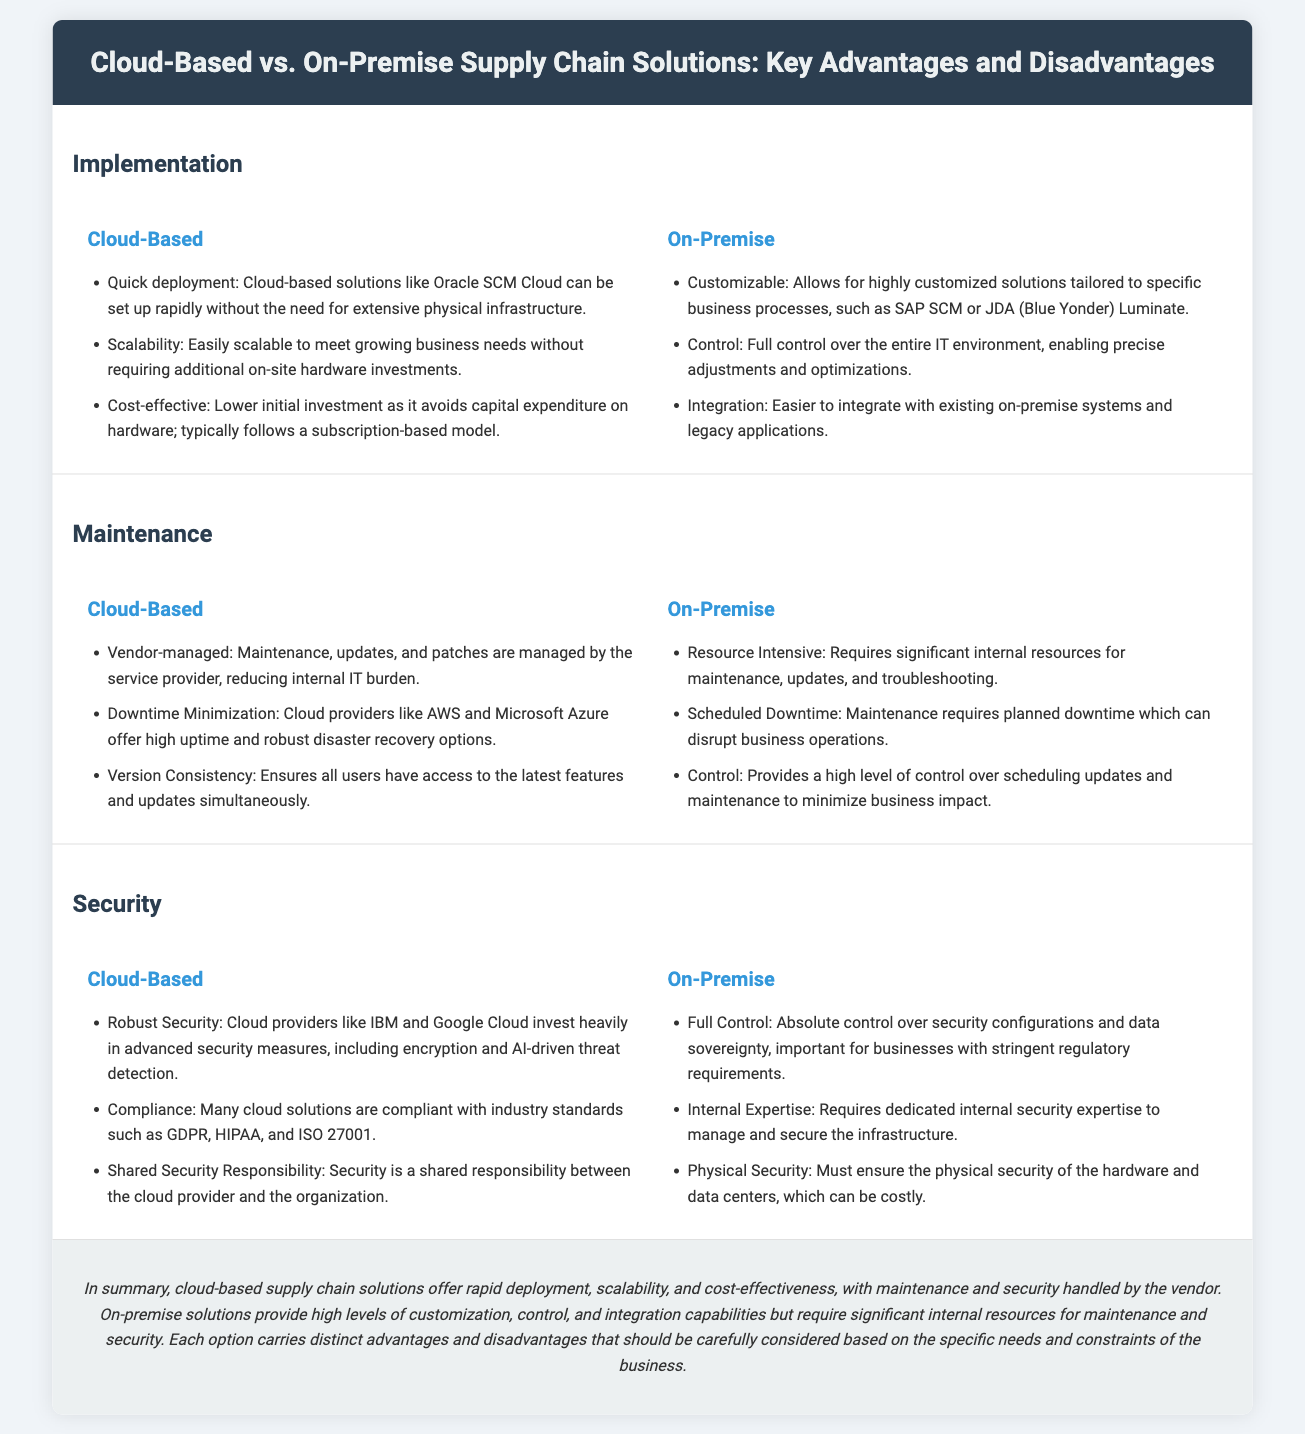What is a key advantage of cloud-based solutions in implementation? The key advantage listed for cloud-based solutions in implementation is quick deployment, as they can be set up rapidly without the need for extensive physical infrastructure.
Answer: Quick deployment What is one disadvantage of on-premise solutions regarding maintenance? One disadvantage of on-premise solutions in maintenance is that they require significant internal resources for maintenance, updates, and troubleshooting.
Answer: Resource Intensive Which cloud provider is mentioned as offering high uptime and robust disaster recovery options? The cloud provider mentioned that offers high uptime and robust disaster recovery options is AWS.
Answer: AWS What type of control do on-premise solutions provide in terms of security? On-premise solutions provide full control over security configurations and data sovereignty in terms of security.
Answer: Full Control What is a notable feature of cloud-based security measures? A notable feature of cloud-based security measures is that cloud providers invest heavily in advanced security measures, including encryption.
Answer: Robust Security How are maintenance efforts handled in cloud-based solutions? Maintenance efforts in cloud-based solutions are managed by the service provider, reducing the internal IT burden.
Answer: Vendor-managed What aspect of cloud-based solutions improves scalability? The aspect of cloud-based solutions that improves scalability is the ability to easily scale to meet growing business needs without requiring additional on-site hardware investments.
Answer: Scalability What is a common model for cloud-based solutions' investment structure? The common model for cloud-based solutions' investment structure is subscription-based.
Answer: Subscription-based How does the conclusion reflect on the advantages of both solutions? The conclusion reflects that cloud-based solutions offer rapid deployment, scalability, and cost-effectiveness, while on-premise solutions provide high levels of customization and control.
Answer: Rapid deployment, scalability, customization, control 